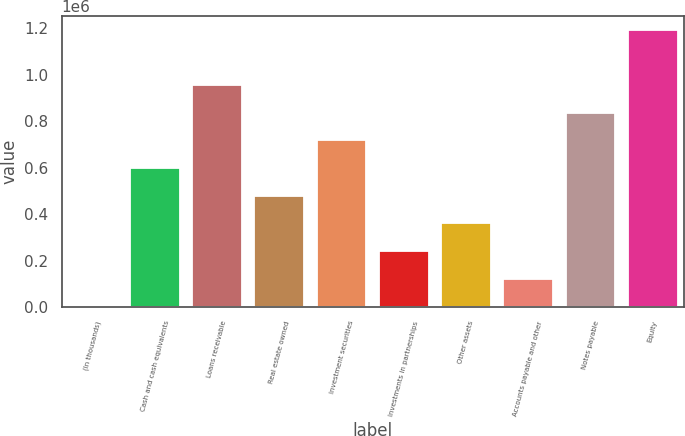Convert chart. <chart><loc_0><loc_0><loc_500><loc_500><bar_chart><fcel>(In thousands)<fcel>Cash and cash equivalents<fcel>Loans receivable<fcel>Real estate owned<fcel>Investment securities<fcel>Investments in partnerships<fcel>Other assets<fcel>Accounts payable and other<fcel>Notes payable<fcel>Equity<nl><fcel>2013<fcel>597712<fcel>955132<fcel>478573<fcel>716852<fcel>240293<fcel>359433<fcel>121153<fcel>835992<fcel>1.19341e+06<nl></chart> 